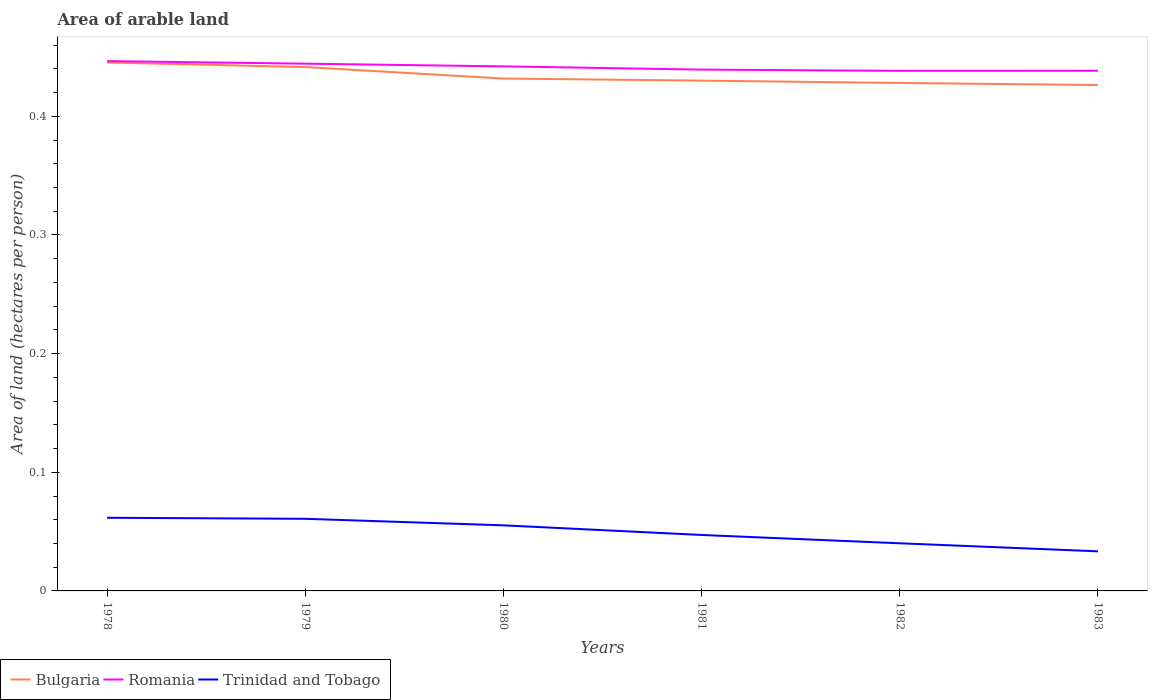Does the line corresponding to Bulgaria intersect with the line corresponding to Romania?
Provide a succinct answer. No. Across all years, what is the maximum total arable land in Bulgaria?
Offer a terse response. 0.43. What is the total total arable land in Romania in the graph?
Keep it short and to the point. 0.01. What is the difference between the highest and the second highest total arable land in Romania?
Offer a very short reply. 0.01. Is the total arable land in Romania strictly greater than the total arable land in Trinidad and Tobago over the years?
Your answer should be compact. No. How many lines are there?
Your answer should be very brief. 3. How many years are there in the graph?
Your answer should be very brief. 6. Does the graph contain any zero values?
Offer a very short reply. No. Where does the legend appear in the graph?
Offer a very short reply. Bottom left. How are the legend labels stacked?
Ensure brevity in your answer.  Horizontal. What is the title of the graph?
Ensure brevity in your answer.  Area of arable land. What is the label or title of the Y-axis?
Ensure brevity in your answer.  Area of land (hectares per person). What is the Area of land (hectares per person) in Bulgaria in 1978?
Your answer should be very brief. 0.45. What is the Area of land (hectares per person) of Romania in 1978?
Provide a succinct answer. 0.45. What is the Area of land (hectares per person) of Trinidad and Tobago in 1978?
Your answer should be compact. 0.06. What is the Area of land (hectares per person) of Bulgaria in 1979?
Ensure brevity in your answer.  0.44. What is the Area of land (hectares per person) in Romania in 1979?
Offer a very short reply. 0.44. What is the Area of land (hectares per person) in Trinidad and Tobago in 1979?
Your answer should be compact. 0.06. What is the Area of land (hectares per person) of Bulgaria in 1980?
Offer a terse response. 0.43. What is the Area of land (hectares per person) in Romania in 1980?
Your response must be concise. 0.44. What is the Area of land (hectares per person) in Trinidad and Tobago in 1980?
Give a very brief answer. 0.06. What is the Area of land (hectares per person) of Bulgaria in 1981?
Ensure brevity in your answer.  0.43. What is the Area of land (hectares per person) of Romania in 1981?
Keep it short and to the point. 0.44. What is the Area of land (hectares per person) in Trinidad and Tobago in 1981?
Your answer should be very brief. 0.05. What is the Area of land (hectares per person) of Bulgaria in 1982?
Offer a very short reply. 0.43. What is the Area of land (hectares per person) in Romania in 1982?
Your answer should be very brief. 0.44. What is the Area of land (hectares per person) of Trinidad and Tobago in 1982?
Provide a succinct answer. 0.04. What is the Area of land (hectares per person) of Bulgaria in 1983?
Provide a short and direct response. 0.43. What is the Area of land (hectares per person) in Romania in 1983?
Your answer should be very brief. 0.44. What is the Area of land (hectares per person) of Trinidad and Tobago in 1983?
Make the answer very short. 0.03. Across all years, what is the maximum Area of land (hectares per person) of Bulgaria?
Ensure brevity in your answer.  0.45. Across all years, what is the maximum Area of land (hectares per person) of Romania?
Offer a very short reply. 0.45. Across all years, what is the maximum Area of land (hectares per person) of Trinidad and Tobago?
Make the answer very short. 0.06. Across all years, what is the minimum Area of land (hectares per person) in Bulgaria?
Give a very brief answer. 0.43. Across all years, what is the minimum Area of land (hectares per person) of Romania?
Offer a very short reply. 0.44. Across all years, what is the minimum Area of land (hectares per person) of Trinidad and Tobago?
Make the answer very short. 0.03. What is the total Area of land (hectares per person) of Bulgaria in the graph?
Your answer should be compact. 2.6. What is the total Area of land (hectares per person) in Romania in the graph?
Ensure brevity in your answer.  2.65. What is the total Area of land (hectares per person) of Trinidad and Tobago in the graph?
Offer a very short reply. 0.3. What is the difference between the Area of land (hectares per person) of Bulgaria in 1978 and that in 1979?
Provide a short and direct response. 0. What is the difference between the Area of land (hectares per person) in Romania in 1978 and that in 1979?
Ensure brevity in your answer.  0. What is the difference between the Area of land (hectares per person) of Trinidad and Tobago in 1978 and that in 1979?
Your response must be concise. 0. What is the difference between the Area of land (hectares per person) in Bulgaria in 1978 and that in 1980?
Ensure brevity in your answer.  0.01. What is the difference between the Area of land (hectares per person) in Romania in 1978 and that in 1980?
Your response must be concise. 0. What is the difference between the Area of land (hectares per person) in Trinidad and Tobago in 1978 and that in 1980?
Offer a very short reply. 0.01. What is the difference between the Area of land (hectares per person) in Bulgaria in 1978 and that in 1981?
Your answer should be compact. 0.02. What is the difference between the Area of land (hectares per person) in Romania in 1978 and that in 1981?
Offer a terse response. 0.01. What is the difference between the Area of land (hectares per person) of Trinidad and Tobago in 1978 and that in 1981?
Make the answer very short. 0.01. What is the difference between the Area of land (hectares per person) of Bulgaria in 1978 and that in 1982?
Ensure brevity in your answer.  0.02. What is the difference between the Area of land (hectares per person) of Romania in 1978 and that in 1982?
Provide a succinct answer. 0.01. What is the difference between the Area of land (hectares per person) of Trinidad and Tobago in 1978 and that in 1982?
Give a very brief answer. 0.02. What is the difference between the Area of land (hectares per person) of Bulgaria in 1978 and that in 1983?
Make the answer very short. 0.02. What is the difference between the Area of land (hectares per person) of Romania in 1978 and that in 1983?
Your answer should be compact. 0.01. What is the difference between the Area of land (hectares per person) of Trinidad and Tobago in 1978 and that in 1983?
Offer a very short reply. 0.03. What is the difference between the Area of land (hectares per person) of Bulgaria in 1979 and that in 1980?
Ensure brevity in your answer.  0.01. What is the difference between the Area of land (hectares per person) in Romania in 1979 and that in 1980?
Provide a succinct answer. 0. What is the difference between the Area of land (hectares per person) of Trinidad and Tobago in 1979 and that in 1980?
Your answer should be very brief. 0.01. What is the difference between the Area of land (hectares per person) in Bulgaria in 1979 and that in 1981?
Give a very brief answer. 0.01. What is the difference between the Area of land (hectares per person) of Romania in 1979 and that in 1981?
Your answer should be very brief. 0.01. What is the difference between the Area of land (hectares per person) in Trinidad and Tobago in 1979 and that in 1981?
Your response must be concise. 0.01. What is the difference between the Area of land (hectares per person) of Bulgaria in 1979 and that in 1982?
Provide a short and direct response. 0.01. What is the difference between the Area of land (hectares per person) in Romania in 1979 and that in 1982?
Keep it short and to the point. 0.01. What is the difference between the Area of land (hectares per person) of Trinidad and Tobago in 1979 and that in 1982?
Provide a short and direct response. 0.02. What is the difference between the Area of land (hectares per person) of Bulgaria in 1979 and that in 1983?
Offer a terse response. 0.02. What is the difference between the Area of land (hectares per person) in Romania in 1979 and that in 1983?
Your answer should be very brief. 0.01. What is the difference between the Area of land (hectares per person) of Trinidad and Tobago in 1979 and that in 1983?
Provide a short and direct response. 0.03. What is the difference between the Area of land (hectares per person) of Bulgaria in 1980 and that in 1981?
Make the answer very short. 0. What is the difference between the Area of land (hectares per person) of Romania in 1980 and that in 1981?
Offer a very short reply. 0. What is the difference between the Area of land (hectares per person) in Trinidad and Tobago in 1980 and that in 1981?
Provide a succinct answer. 0.01. What is the difference between the Area of land (hectares per person) of Bulgaria in 1980 and that in 1982?
Make the answer very short. 0. What is the difference between the Area of land (hectares per person) of Romania in 1980 and that in 1982?
Provide a short and direct response. 0. What is the difference between the Area of land (hectares per person) of Trinidad and Tobago in 1980 and that in 1982?
Make the answer very short. 0.02. What is the difference between the Area of land (hectares per person) in Bulgaria in 1980 and that in 1983?
Your answer should be very brief. 0.01. What is the difference between the Area of land (hectares per person) of Romania in 1980 and that in 1983?
Offer a terse response. 0. What is the difference between the Area of land (hectares per person) of Trinidad and Tobago in 1980 and that in 1983?
Offer a very short reply. 0.02. What is the difference between the Area of land (hectares per person) of Bulgaria in 1981 and that in 1982?
Make the answer very short. 0. What is the difference between the Area of land (hectares per person) of Romania in 1981 and that in 1982?
Provide a short and direct response. 0. What is the difference between the Area of land (hectares per person) of Trinidad and Tobago in 1981 and that in 1982?
Provide a succinct answer. 0.01. What is the difference between the Area of land (hectares per person) in Bulgaria in 1981 and that in 1983?
Offer a very short reply. 0. What is the difference between the Area of land (hectares per person) in Romania in 1981 and that in 1983?
Provide a short and direct response. 0. What is the difference between the Area of land (hectares per person) in Trinidad and Tobago in 1981 and that in 1983?
Offer a terse response. 0.01. What is the difference between the Area of land (hectares per person) of Bulgaria in 1982 and that in 1983?
Offer a very short reply. 0. What is the difference between the Area of land (hectares per person) of Romania in 1982 and that in 1983?
Your answer should be very brief. -0. What is the difference between the Area of land (hectares per person) in Trinidad and Tobago in 1982 and that in 1983?
Your answer should be compact. 0.01. What is the difference between the Area of land (hectares per person) of Bulgaria in 1978 and the Area of land (hectares per person) of Trinidad and Tobago in 1979?
Ensure brevity in your answer.  0.38. What is the difference between the Area of land (hectares per person) of Romania in 1978 and the Area of land (hectares per person) of Trinidad and Tobago in 1979?
Make the answer very short. 0.39. What is the difference between the Area of land (hectares per person) in Bulgaria in 1978 and the Area of land (hectares per person) in Romania in 1980?
Provide a short and direct response. 0. What is the difference between the Area of land (hectares per person) of Bulgaria in 1978 and the Area of land (hectares per person) of Trinidad and Tobago in 1980?
Your response must be concise. 0.39. What is the difference between the Area of land (hectares per person) in Romania in 1978 and the Area of land (hectares per person) in Trinidad and Tobago in 1980?
Keep it short and to the point. 0.39. What is the difference between the Area of land (hectares per person) in Bulgaria in 1978 and the Area of land (hectares per person) in Romania in 1981?
Make the answer very short. 0.01. What is the difference between the Area of land (hectares per person) in Bulgaria in 1978 and the Area of land (hectares per person) in Trinidad and Tobago in 1981?
Your response must be concise. 0.4. What is the difference between the Area of land (hectares per person) of Romania in 1978 and the Area of land (hectares per person) of Trinidad and Tobago in 1981?
Offer a terse response. 0.4. What is the difference between the Area of land (hectares per person) of Bulgaria in 1978 and the Area of land (hectares per person) of Romania in 1982?
Your answer should be very brief. 0.01. What is the difference between the Area of land (hectares per person) in Bulgaria in 1978 and the Area of land (hectares per person) in Trinidad and Tobago in 1982?
Your answer should be very brief. 0.41. What is the difference between the Area of land (hectares per person) in Romania in 1978 and the Area of land (hectares per person) in Trinidad and Tobago in 1982?
Make the answer very short. 0.41. What is the difference between the Area of land (hectares per person) in Bulgaria in 1978 and the Area of land (hectares per person) in Romania in 1983?
Your answer should be compact. 0.01. What is the difference between the Area of land (hectares per person) in Bulgaria in 1978 and the Area of land (hectares per person) in Trinidad and Tobago in 1983?
Provide a succinct answer. 0.41. What is the difference between the Area of land (hectares per person) of Romania in 1978 and the Area of land (hectares per person) of Trinidad and Tobago in 1983?
Provide a short and direct response. 0.41. What is the difference between the Area of land (hectares per person) of Bulgaria in 1979 and the Area of land (hectares per person) of Romania in 1980?
Your response must be concise. -0. What is the difference between the Area of land (hectares per person) in Bulgaria in 1979 and the Area of land (hectares per person) in Trinidad and Tobago in 1980?
Provide a succinct answer. 0.39. What is the difference between the Area of land (hectares per person) in Romania in 1979 and the Area of land (hectares per person) in Trinidad and Tobago in 1980?
Offer a terse response. 0.39. What is the difference between the Area of land (hectares per person) of Bulgaria in 1979 and the Area of land (hectares per person) of Romania in 1981?
Your answer should be very brief. 0. What is the difference between the Area of land (hectares per person) in Bulgaria in 1979 and the Area of land (hectares per person) in Trinidad and Tobago in 1981?
Provide a short and direct response. 0.39. What is the difference between the Area of land (hectares per person) in Romania in 1979 and the Area of land (hectares per person) in Trinidad and Tobago in 1981?
Make the answer very short. 0.4. What is the difference between the Area of land (hectares per person) of Bulgaria in 1979 and the Area of land (hectares per person) of Romania in 1982?
Give a very brief answer. 0. What is the difference between the Area of land (hectares per person) of Bulgaria in 1979 and the Area of land (hectares per person) of Trinidad and Tobago in 1982?
Make the answer very short. 0.4. What is the difference between the Area of land (hectares per person) of Romania in 1979 and the Area of land (hectares per person) of Trinidad and Tobago in 1982?
Your answer should be very brief. 0.4. What is the difference between the Area of land (hectares per person) in Bulgaria in 1979 and the Area of land (hectares per person) in Romania in 1983?
Your response must be concise. 0. What is the difference between the Area of land (hectares per person) in Bulgaria in 1979 and the Area of land (hectares per person) in Trinidad and Tobago in 1983?
Provide a succinct answer. 0.41. What is the difference between the Area of land (hectares per person) in Romania in 1979 and the Area of land (hectares per person) in Trinidad and Tobago in 1983?
Provide a succinct answer. 0.41. What is the difference between the Area of land (hectares per person) of Bulgaria in 1980 and the Area of land (hectares per person) of Romania in 1981?
Offer a very short reply. -0.01. What is the difference between the Area of land (hectares per person) of Bulgaria in 1980 and the Area of land (hectares per person) of Trinidad and Tobago in 1981?
Your answer should be very brief. 0.38. What is the difference between the Area of land (hectares per person) of Romania in 1980 and the Area of land (hectares per person) of Trinidad and Tobago in 1981?
Provide a succinct answer. 0.4. What is the difference between the Area of land (hectares per person) of Bulgaria in 1980 and the Area of land (hectares per person) of Romania in 1982?
Provide a short and direct response. -0.01. What is the difference between the Area of land (hectares per person) of Bulgaria in 1980 and the Area of land (hectares per person) of Trinidad and Tobago in 1982?
Make the answer very short. 0.39. What is the difference between the Area of land (hectares per person) in Romania in 1980 and the Area of land (hectares per person) in Trinidad and Tobago in 1982?
Your answer should be very brief. 0.4. What is the difference between the Area of land (hectares per person) of Bulgaria in 1980 and the Area of land (hectares per person) of Romania in 1983?
Offer a terse response. -0.01. What is the difference between the Area of land (hectares per person) of Bulgaria in 1980 and the Area of land (hectares per person) of Trinidad and Tobago in 1983?
Make the answer very short. 0.4. What is the difference between the Area of land (hectares per person) of Romania in 1980 and the Area of land (hectares per person) of Trinidad and Tobago in 1983?
Your answer should be compact. 0.41. What is the difference between the Area of land (hectares per person) of Bulgaria in 1981 and the Area of land (hectares per person) of Romania in 1982?
Offer a terse response. -0.01. What is the difference between the Area of land (hectares per person) of Bulgaria in 1981 and the Area of land (hectares per person) of Trinidad and Tobago in 1982?
Offer a terse response. 0.39. What is the difference between the Area of land (hectares per person) in Romania in 1981 and the Area of land (hectares per person) in Trinidad and Tobago in 1982?
Provide a short and direct response. 0.4. What is the difference between the Area of land (hectares per person) of Bulgaria in 1981 and the Area of land (hectares per person) of Romania in 1983?
Ensure brevity in your answer.  -0.01. What is the difference between the Area of land (hectares per person) in Bulgaria in 1981 and the Area of land (hectares per person) in Trinidad and Tobago in 1983?
Your answer should be compact. 0.4. What is the difference between the Area of land (hectares per person) of Romania in 1981 and the Area of land (hectares per person) of Trinidad and Tobago in 1983?
Your response must be concise. 0.41. What is the difference between the Area of land (hectares per person) in Bulgaria in 1982 and the Area of land (hectares per person) in Romania in 1983?
Your answer should be very brief. -0.01. What is the difference between the Area of land (hectares per person) in Bulgaria in 1982 and the Area of land (hectares per person) in Trinidad and Tobago in 1983?
Offer a terse response. 0.39. What is the difference between the Area of land (hectares per person) of Romania in 1982 and the Area of land (hectares per person) of Trinidad and Tobago in 1983?
Provide a succinct answer. 0.41. What is the average Area of land (hectares per person) of Bulgaria per year?
Provide a short and direct response. 0.43. What is the average Area of land (hectares per person) in Romania per year?
Ensure brevity in your answer.  0.44. What is the average Area of land (hectares per person) of Trinidad and Tobago per year?
Provide a short and direct response. 0.05. In the year 1978, what is the difference between the Area of land (hectares per person) of Bulgaria and Area of land (hectares per person) of Romania?
Ensure brevity in your answer.  -0. In the year 1978, what is the difference between the Area of land (hectares per person) of Bulgaria and Area of land (hectares per person) of Trinidad and Tobago?
Provide a short and direct response. 0.38. In the year 1978, what is the difference between the Area of land (hectares per person) of Romania and Area of land (hectares per person) of Trinidad and Tobago?
Ensure brevity in your answer.  0.38. In the year 1979, what is the difference between the Area of land (hectares per person) in Bulgaria and Area of land (hectares per person) in Romania?
Your response must be concise. -0. In the year 1979, what is the difference between the Area of land (hectares per person) of Bulgaria and Area of land (hectares per person) of Trinidad and Tobago?
Make the answer very short. 0.38. In the year 1979, what is the difference between the Area of land (hectares per person) in Romania and Area of land (hectares per person) in Trinidad and Tobago?
Your answer should be very brief. 0.38. In the year 1980, what is the difference between the Area of land (hectares per person) in Bulgaria and Area of land (hectares per person) in Romania?
Ensure brevity in your answer.  -0.01. In the year 1980, what is the difference between the Area of land (hectares per person) in Bulgaria and Area of land (hectares per person) in Trinidad and Tobago?
Offer a terse response. 0.38. In the year 1980, what is the difference between the Area of land (hectares per person) in Romania and Area of land (hectares per person) in Trinidad and Tobago?
Make the answer very short. 0.39. In the year 1981, what is the difference between the Area of land (hectares per person) in Bulgaria and Area of land (hectares per person) in Romania?
Your response must be concise. -0.01. In the year 1981, what is the difference between the Area of land (hectares per person) of Bulgaria and Area of land (hectares per person) of Trinidad and Tobago?
Offer a very short reply. 0.38. In the year 1981, what is the difference between the Area of land (hectares per person) in Romania and Area of land (hectares per person) in Trinidad and Tobago?
Your response must be concise. 0.39. In the year 1982, what is the difference between the Area of land (hectares per person) in Bulgaria and Area of land (hectares per person) in Romania?
Give a very brief answer. -0.01. In the year 1982, what is the difference between the Area of land (hectares per person) in Bulgaria and Area of land (hectares per person) in Trinidad and Tobago?
Your response must be concise. 0.39. In the year 1982, what is the difference between the Area of land (hectares per person) of Romania and Area of land (hectares per person) of Trinidad and Tobago?
Make the answer very short. 0.4. In the year 1983, what is the difference between the Area of land (hectares per person) of Bulgaria and Area of land (hectares per person) of Romania?
Your response must be concise. -0.01. In the year 1983, what is the difference between the Area of land (hectares per person) of Bulgaria and Area of land (hectares per person) of Trinidad and Tobago?
Keep it short and to the point. 0.39. In the year 1983, what is the difference between the Area of land (hectares per person) of Romania and Area of land (hectares per person) of Trinidad and Tobago?
Offer a terse response. 0.41. What is the ratio of the Area of land (hectares per person) of Bulgaria in 1978 to that in 1979?
Ensure brevity in your answer.  1.01. What is the ratio of the Area of land (hectares per person) in Trinidad and Tobago in 1978 to that in 1979?
Give a very brief answer. 1.01. What is the ratio of the Area of land (hectares per person) of Bulgaria in 1978 to that in 1980?
Offer a very short reply. 1.03. What is the ratio of the Area of land (hectares per person) of Romania in 1978 to that in 1980?
Make the answer very short. 1.01. What is the ratio of the Area of land (hectares per person) of Trinidad and Tobago in 1978 to that in 1980?
Provide a succinct answer. 1.12. What is the ratio of the Area of land (hectares per person) in Bulgaria in 1978 to that in 1981?
Provide a short and direct response. 1.04. What is the ratio of the Area of land (hectares per person) in Romania in 1978 to that in 1981?
Your answer should be compact. 1.02. What is the ratio of the Area of land (hectares per person) in Trinidad and Tobago in 1978 to that in 1981?
Offer a very short reply. 1.31. What is the ratio of the Area of land (hectares per person) in Bulgaria in 1978 to that in 1982?
Your response must be concise. 1.04. What is the ratio of the Area of land (hectares per person) in Romania in 1978 to that in 1982?
Provide a short and direct response. 1.02. What is the ratio of the Area of land (hectares per person) of Trinidad and Tobago in 1978 to that in 1982?
Ensure brevity in your answer.  1.54. What is the ratio of the Area of land (hectares per person) of Bulgaria in 1978 to that in 1983?
Ensure brevity in your answer.  1.04. What is the ratio of the Area of land (hectares per person) in Romania in 1978 to that in 1983?
Provide a succinct answer. 1.02. What is the ratio of the Area of land (hectares per person) of Trinidad and Tobago in 1978 to that in 1983?
Ensure brevity in your answer.  1.85. What is the ratio of the Area of land (hectares per person) of Bulgaria in 1979 to that in 1980?
Make the answer very short. 1.02. What is the ratio of the Area of land (hectares per person) in Romania in 1979 to that in 1980?
Offer a terse response. 1.01. What is the ratio of the Area of land (hectares per person) of Trinidad and Tobago in 1979 to that in 1980?
Keep it short and to the point. 1.1. What is the ratio of the Area of land (hectares per person) in Bulgaria in 1979 to that in 1981?
Your answer should be very brief. 1.03. What is the ratio of the Area of land (hectares per person) in Romania in 1979 to that in 1981?
Make the answer very short. 1.01. What is the ratio of the Area of land (hectares per person) of Trinidad and Tobago in 1979 to that in 1981?
Offer a terse response. 1.29. What is the ratio of the Area of land (hectares per person) in Bulgaria in 1979 to that in 1982?
Offer a terse response. 1.03. What is the ratio of the Area of land (hectares per person) in Romania in 1979 to that in 1982?
Keep it short and to the point. 1.01. What is the ratio of the Area of land (hectares per person) in Trinidad and Tobago in 1979 to that in 1982?
Offer a very short reply. 1.51. What is the ratio of the Area of land (hectares per person) in Bulgaria in 1979 to that in 1983?
Provide a succinct answer. 1.04. What is the ratio of the Area of land (hectares per person) in Romania in 1979 to that in 1983?
Provide a short and direct response. 1.01. What is the ratio of the Area of land (hectares per person) of Trinidad and Tobago in 1979 to that in 1983?
Ensure brevity in your answer.  1.82. What is the ratio of the Area of land (hectares per person) of Bulgaria in 1980 to that in 1981?
Your response must be concise. 1. What is the ratio of the Area of land (hectares per person) in Romania in 1980 to that in 1981?
Ensure brevity in your answer.  1.01. What is the ratio of the Area of land (hectares per person) in Trinidad and Tobago in 1980 to that in 1981?
Make the answer very short. 1.17. What is the ratio of the Area of land (hectares per person) in Bulgaria in 1980 to that in 1982?
Give a very brief answer. 1.01. What is the ratio of the Area of land (hectares per person) in Romania in 1980 to that in 1982?
Provide a short and direct response. 1.01. What is the ratio of the Area of land (hectares per person) of Trinidad and Tobago in 1980 to that in 1982?
Offer a terse response. 1.38. What is the ratio of the Area of land (hectares per person) in Bulgaria in 1980 to that in 1983?
Offer a very short reply. 1.01. What is the ratio of the Area of land (hectares per person) in Romania in 1980 to that in 1983?
Keep it short and to the point. 1.01. What is the ratio of the Area of land (hectares per person) of Trinidad and Tobago in 1980 to that in 1983?
Your answer should be very brief. 1.66. What is the ratio of the Area of land (hectares per person) in Trinidad and Tobago in 1981 to that in 1982?
Your answer should be very brief. 1.17. What is the ratio of the Area of land (hectares per person) of Bulgaria in 1981 to that in 1983?
Give a very brief answer. 1.01. What is the ratio of the Area of land (hectares per person) of Trinidad and Tobago in 1981 to that in 1983?
Your response must be concise. 1.41. What is the ratio of the Area of land (hectares per person) in Bulgaria in 1982 to that in 1983?
Offer a very short reply. 1. What is the ratio of the Area of land (hectares per person) of Romania in 1982 to that in 1983?
Keep it short and to the point. 1. What is the ratio of the Area of land (hectares per person) of Trinidad and Tobago in 1982 to that in 1983?
Provide a short and direct response. 1.2. What is the difference between the highest and the second highest Area of land (hectares per person) in Bulgaria?
Give a very brief answer. 0. What is the difference between the highest and the second highest Area of land (hectares per person) in Romania?
Give a very brief answer. 0. What is the difference between the highest and the second highest Area of land (hectares per person) of Trinidad and Tobago?
Ensure brevity in your answer.  0. What is the difference between the highest and the lowest Area of land (hectares per person) in Bulgaria?
Give a very brief answer. 0.02. What is the difference between the highest and the lowest Area of land (hectares per person) of Romania?
Offer a very short reply. 0.01. What is the difference between the highest and the lowest Area of land (hectares per person) of Trinidad and Tobago?
Give a very brief answer. 0.03. 